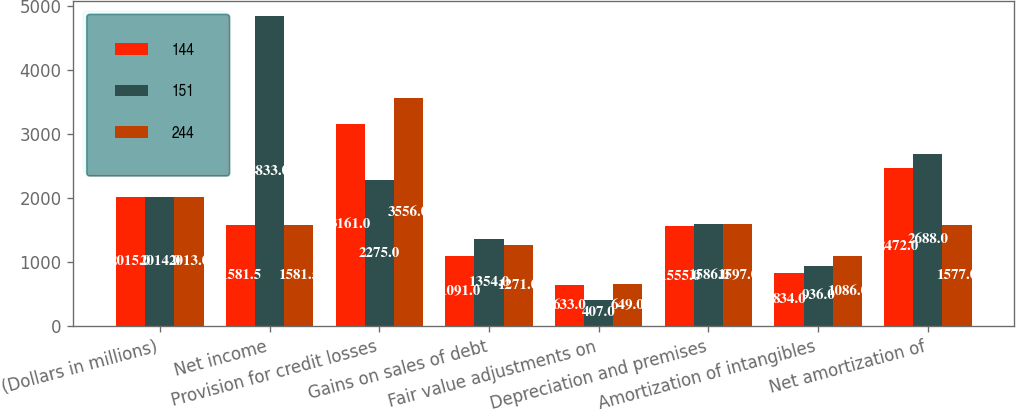Convert chart. <chart><loc_0><loc_0><loc_500><loc_500><stacked_bar_chart><ecel><fcel>(Dollars in millions)<fcel>Net income<fcel>Provision for credit losses<fcel>Gains on sales of debt<fcel>Fair value adjustments on<fcel>Depreciation and premises<fcel>Amortization of intangibles<fcel>Net amortization of<nl><fcel>144<fcel>2015<fcel>1581.5<fcel>3161<fcel>1091<fcel>633<fcel>1555<fcel>834<fcel>2472<nl><fcel>151<fcel>2014<fcel>4833<fcel>2275<fcel>1354<fcel>407<fcel>1586<fcel>936<fcel>2688<nl><fcel>244<fcel>2013<fcel>1581.5<fcel>3556<fcel>1271<fcel>649<fcel>1597<fcel>1086<fcel>1577<nl></chart> 